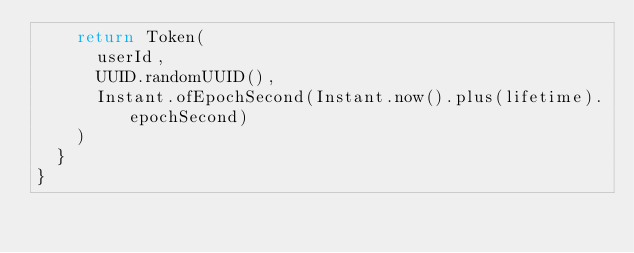Convert code to text. <code><loc_0><loc_0><loc_500><loc_500><_Kotlin_>		return Token(
			userId,
			UUID.randomUUID(),
			Instant.ofEpochSecond(Instant.now().plus(lifetime).epochSecond)
		)
	}
}</code> 